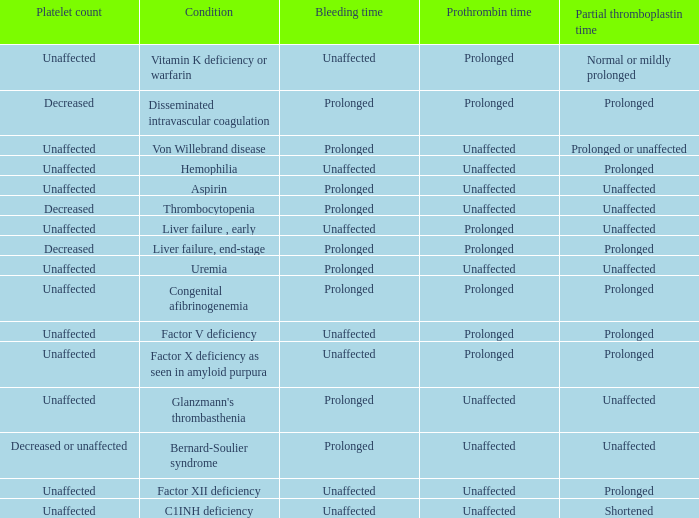Which Condition has an unaffected Partial thromboplastin time, Platelet count, and a Prothrombin time? Aspirin, Uremia, Glanzmann's thrombasthenia. 